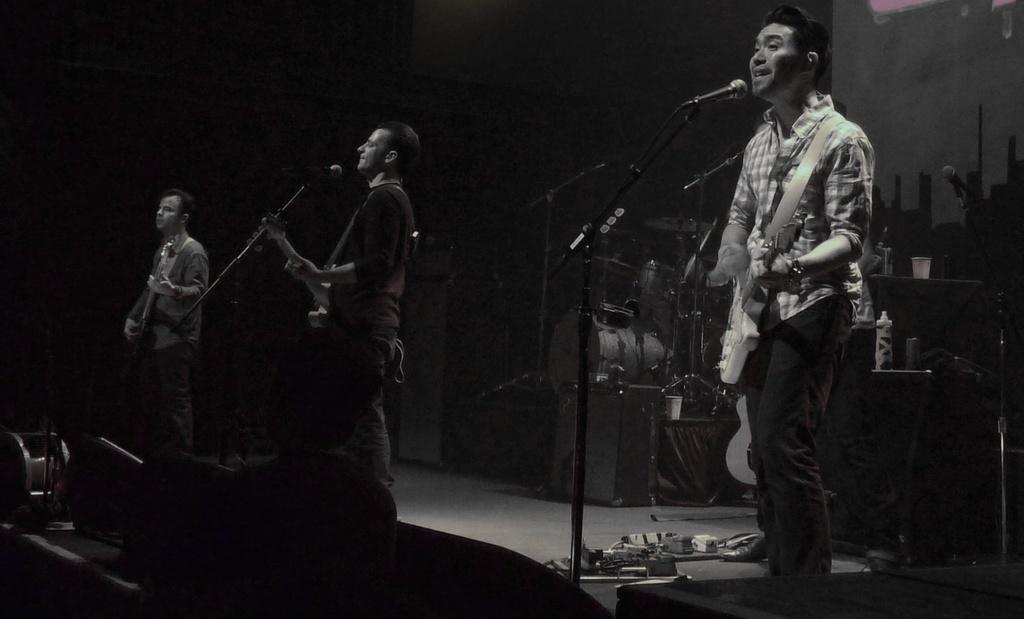How would you summarize this image in a sentence or two? On the stage we can see 3 persons holding guitar and playing. There is a microphone. In the background we can see musical instruments. 